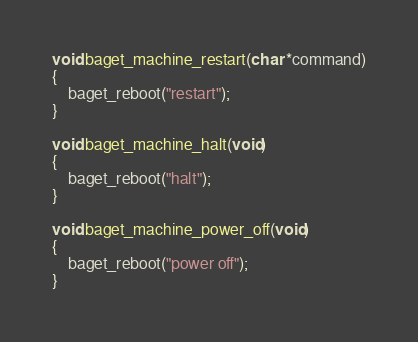<code> <loc_0><loc_0><loc_500><loc_500><_C_>

void baget_machine_restart(char *command)
{
	baget_reboot("restart");
}

void baget_machine_halt(void)
{
	baget_reboot("halt");
}

void baget_machine_power_off(void)
{
	baget_reboot("power off");
}
</code> 